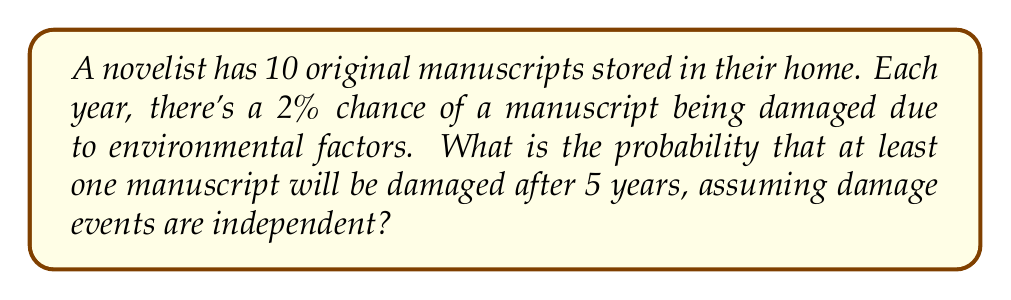Can you solve this math problem? Let's approach this step-by-step:

1) First, let's calculate the probability of a single manuscript remaining undamaged after 5 years:
   $P(\text{undamaged}) = (1 - 0.02)^5 = 0.98^5 \approx 0.9039$

2) Now, the probability of a single manuscript being damaged after 5 years is:
   $P(\text{damaged}) = 1 - P(\text{undamaged}) = 1 - 0.9039 = 0.0961$

3) We want the probability of at least one manuscript being damaged out of 10. It's easier to calculate the probability of no manuscripts being damaged and then subtract from 1:

4) Probability of all 10 manuscripts remaining undamaged:
   $P(\text{all undamaged}) = 0.9039^{10} \approx 0.3660$

5) Therefore, the probability of at least one manuscript being damaged is:
   $P(\text{at least one damaged}) = 1 - P(\text{all undamaged})$
   $= 1 - 0.3660 = 0.6340$

Thus, there's approximately a 63.40% chance that at least one manuscript will be damaged after 5 years.
Answer: 0.6340 or 63.40% 